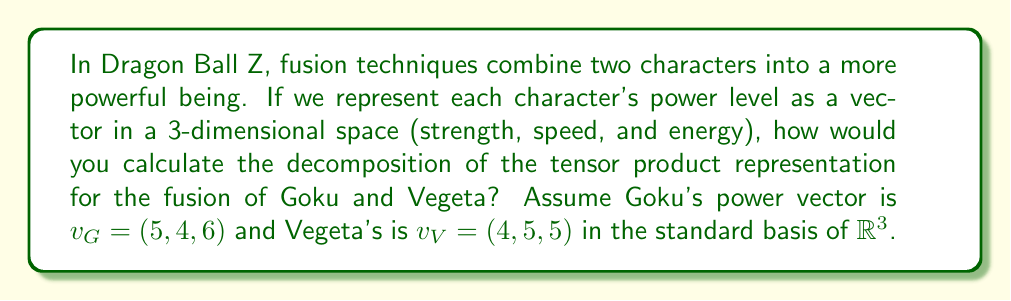Teach me how to tackle this problem. To solve this problem, we'll follow these steps:

1) First, we need to understand that the tensor product of two 3-dimensional vectors results in a 9-dimensional vector space. The basis for this space is the set of all pairs $(e_i, e_j)$ where $e_i$ and $e_j$ are standard basis vectors of $\mathbb{R}^3$.

2) The tensor product $v_G \otimes v_V$ is calculated as:

   $$(5, 4, 6) \otimes (4, 5, 5) = (20, 25, 25, 16, 20, 20, 24, 30, 30)$$

3) This 9-dimensional vector can be seen as a $3 \times 3$ matrix:

   $$\begin{pmatrix}
   20 & 25 & 25 \\
   16 & 20 & 20 \\
   24 & 30 & 30
   \end{pmatrix}$$

4) To decompose this representation, we need to find its irreducible components. In this case, we can decompose it into symmetric and antisymmetric parts:

   Symmetric part:
   $$S = \frac{1}{2}(v_G \otimes v_V + v_V \otimes v_G)$$

   Antisymmetric part:
   $$A = \frac{1}{2}(v_G \otimes v_V - v_V \otimes v_G)$$

5) Calculating these:

   $$S = \frac{1}{2}\begin{pmatrix}
   40 & 41 & 45 \\
   41 & 40 & 45 \\
   45 & 45 & 60
   \end{pmatrix}$$

   $$A = \frac{1}{2}\begin{pmatrix}
   0 & 9 & 5 \\
   -9 & 0 & -5 \\
   3 & 15 & 0
   \end{pmatrix}$$

6) The symmetric part $S$ represents the "fusion" power, while the antisymmetric part $A$ represents the "difference" in their powers.

7) The decomposition is thus $v_G \otimes v_V = S \oplus A$, where $S$ is a 6-dimensional representation (symmetric 3x3 matrices) and $A$ is a 3-dimensional representation (antisymmetric 3x3 matrices).
Answer: $v_G \otimes v_V = S \oplus A$, where $S$ is 6-dimensional and $A$ is 3-dimensional. 